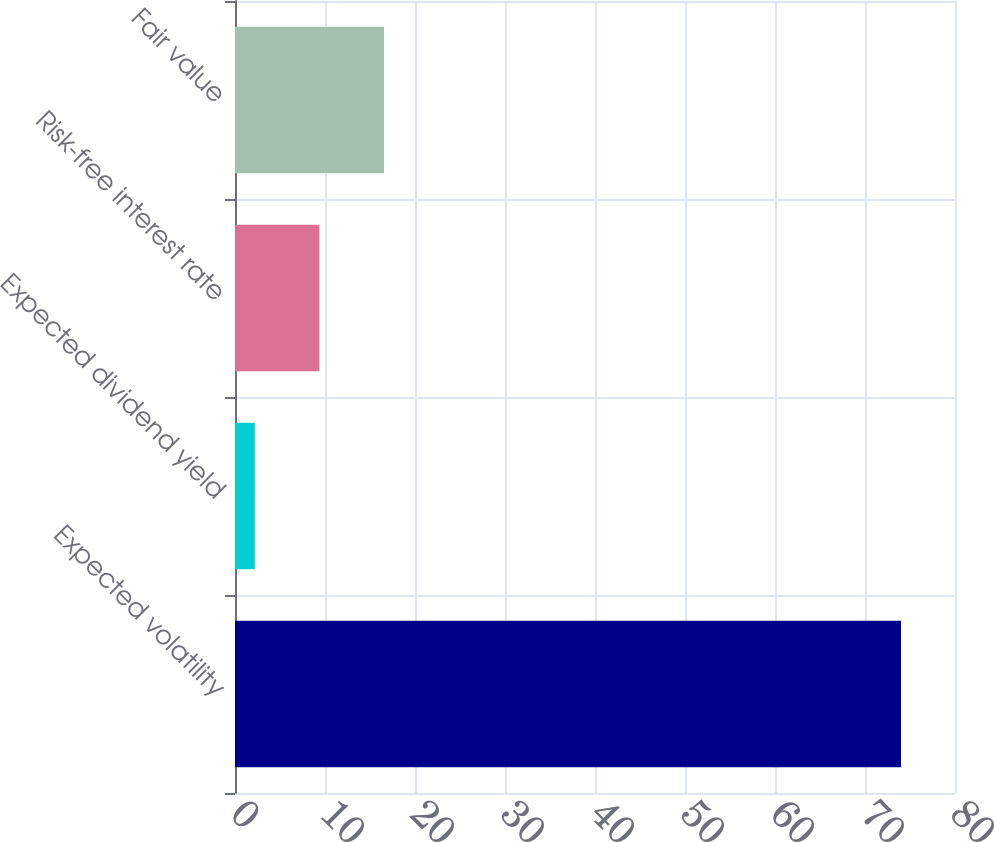Convert chart. <chart><loc_0><loc_0><loc_500><loc_500><bar_chart><fcel>Expected volatility<fcel>Expected dividend yield<fcel>Risk-free interest rate<fcel>Fair value<nl><fcel>74<fcel>2.2<fcel>9.38<fcel>16.56<nl></chart> 